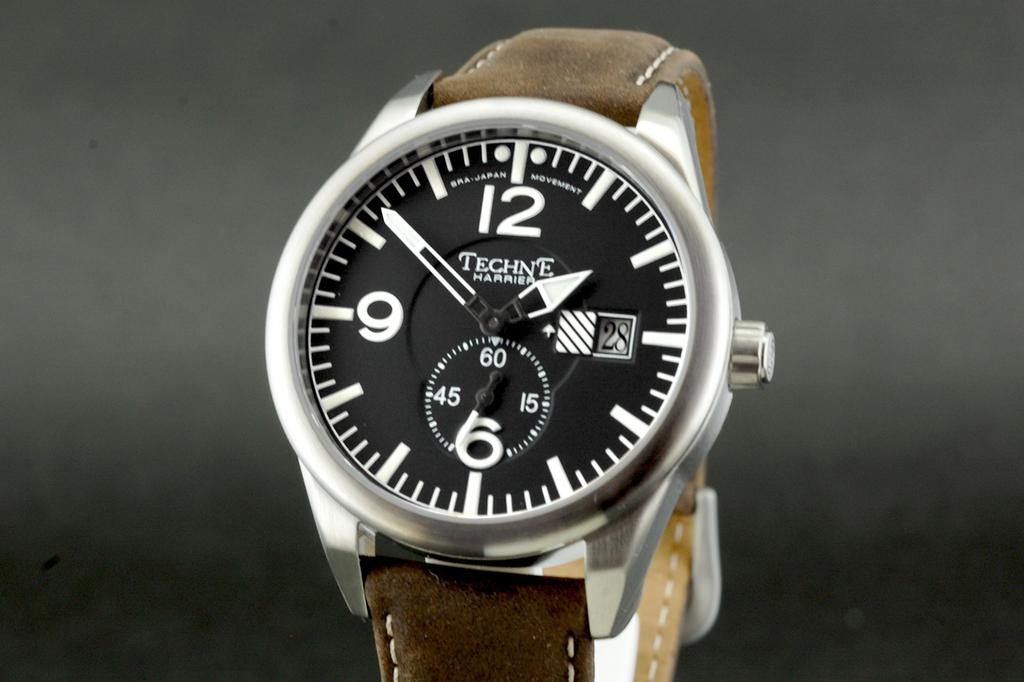<image>
Render a clear and concise summary of the photo. The Techne Harrier watch has a brown band is on a grey background. 